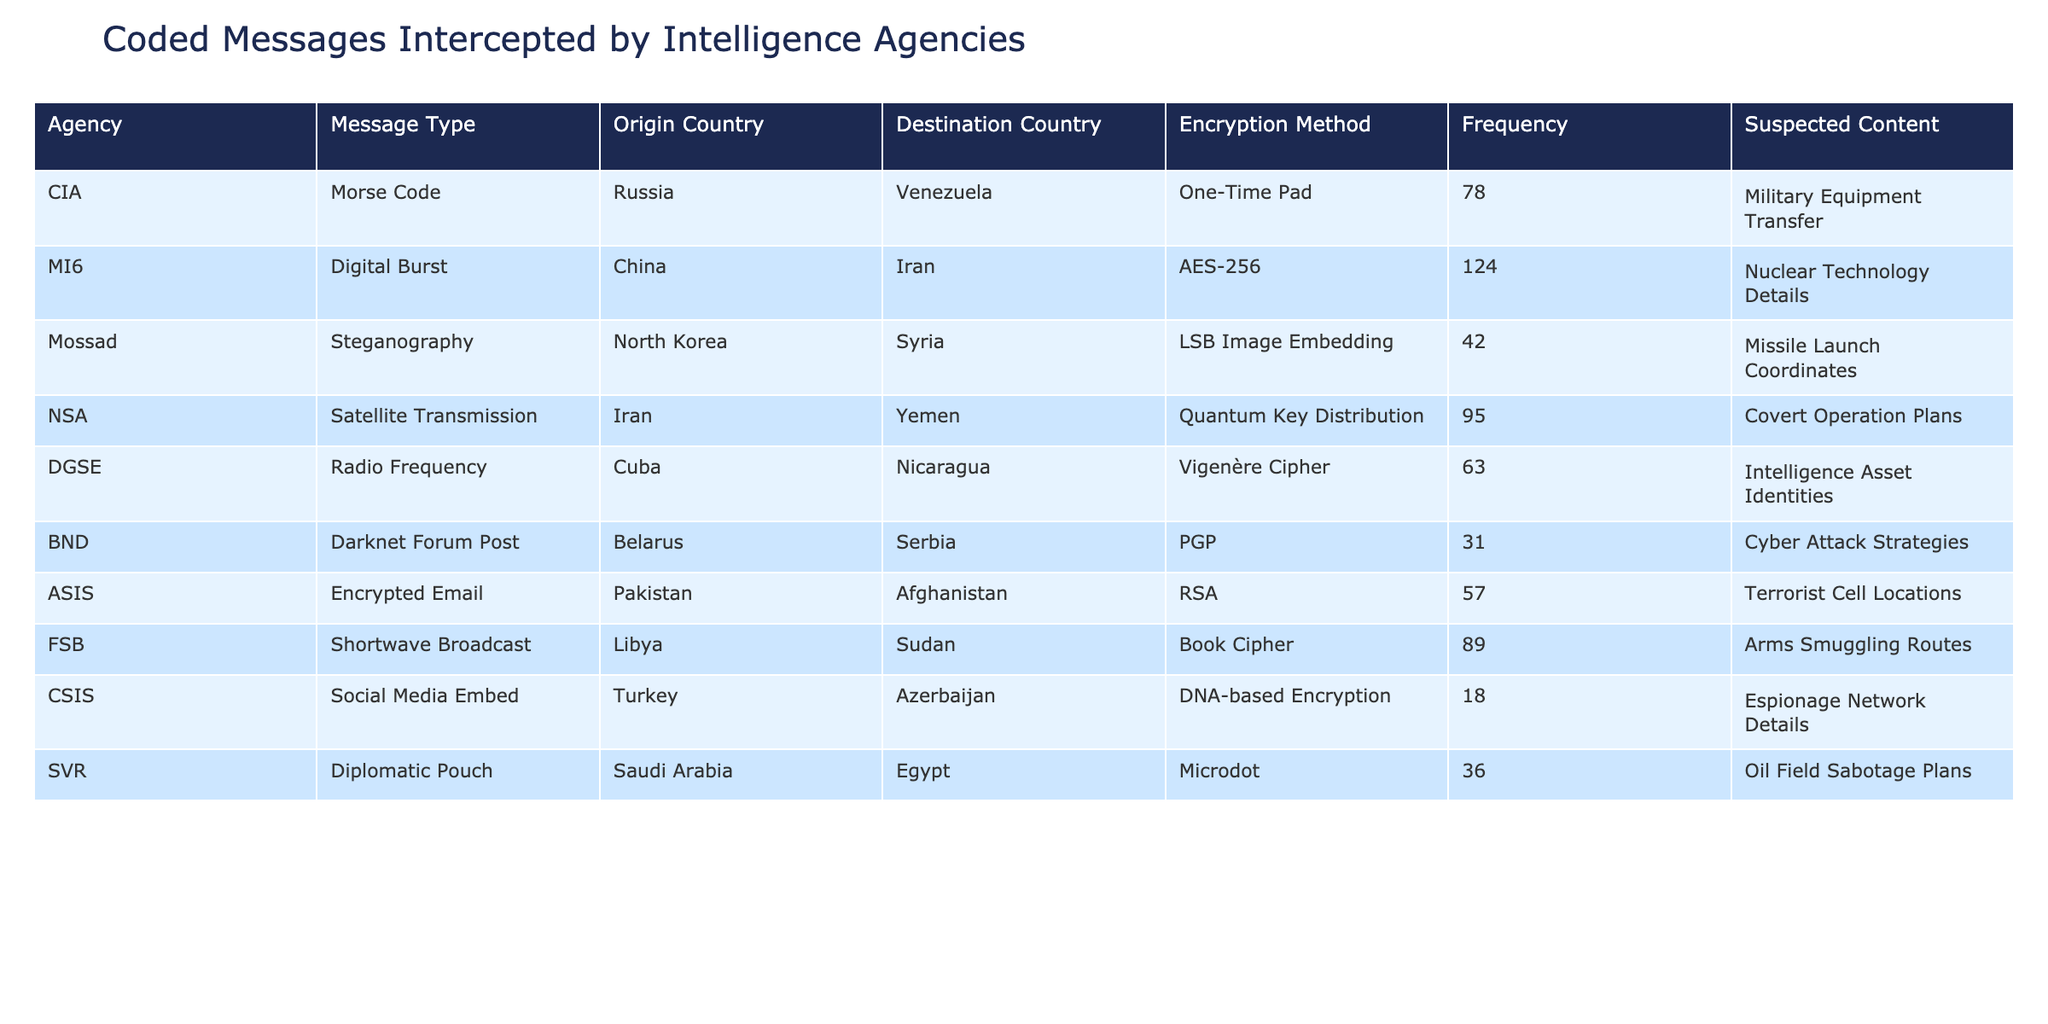What is the origin country for the highest number of coded messages? The highest frequency of coded messages intercepted is 124, which originates from China. Therefore, the country with the highest number of coded messages is China.
Answer: China What is the total frequency of messages intercepted from Russia? The table shows one message type from Russia with a frequency of 78. Since this is the only entry, the total frequency is 78.
Answer: 78 Is there any coded message intercepted that used the AES-256 encryption method? There is one message from China to Iran that uses AES-256 encryption, as indicated in the table. Therefore, the statement is true.
Answer: Yes Which message type has the least frequency and what is that frequency? The table lists BND's Darknet Forum Post with the least frequency, which is 31. Thus, the message type with the least frequency is this one, with a frequency of 31.
Answer: Darknet Forum Post, 31 What is the combined frequency of messages from North Korea and Iran? The message from North Korea has a frequency of 42, and the frequency from Iran is 95. Adding these two frequencies together gives us 42 + 95 = 137.
Answer: 137 Which agency intercepted messages about military equipment transfer? The CIA intercepted messages about military equipment transfer, which is indicated with a frequency of 78 in the table.
Answer: CIA How many agencies have intercepted messages with a frequency of over 80? The agencies with frequencies over 80 are CIA (78), MI6 (124), NSA (95), and FSB (89). This totals four agencies, so the answer is 4.
Answer: 4 What is the average frequency of coded messages intercepted from countries in the Middle East (Iran, Yemen, Saudi Arabia)? The frequencies for messages from Iran (95), Yemen (95), and Saudi Arabia (36) need to be summed: 95 + 95 + 36 = 226. There are three entries, so the average frequency is 226/3 ≈ 75.33.
Answer: 75.33 Is there a coded message intercepted that relates to nuclear technology? The table shows that MI6 intercepted messages concerning nuclear technology details, hence the answer is yes.
Answer: Yes Which message has the highest suspected content regarding sabotage plans? The table includes two suspected sabotage plans: one from Saudi Arabia (oil field sabotage plans) and one from Iran (covert operation plans). However, the specific content of actions is different, making it a qualitative question rather than quantitative. The highest explicitly related to sabotage is from Saudi Arabia.
Answer: Oil Field Sabotage Plans 